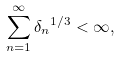<formula> <loc_0><loc_0><loc_500><loc_500>\sum _ { n = 1 } ^ { \infty } { \delta _ { n } } ^ { 1 / 3 } < \infty ,</formula> 